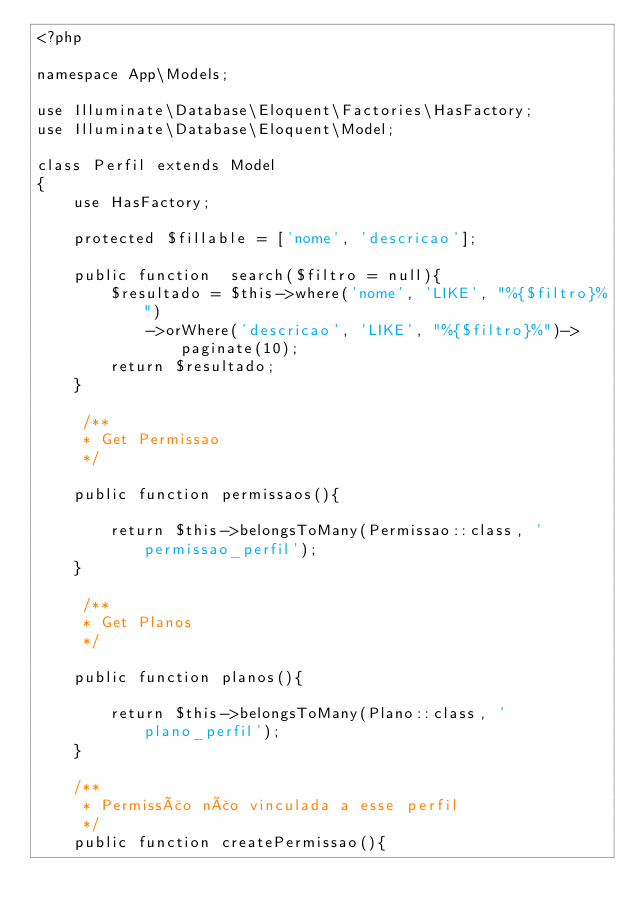Convert code to text. <code><loc_0><loc_0><loc_500><loc_500><_PHP_><?php

namespace App\Models;

use Illuminate\Database\Eloquent\Factories\HasFactory;
use Illuminate\Database\Eloquent\Model;

class Perfil extends Model
{
    use HasFactory;
    
    protected $fillable = ['nome', 'descricao'];

    public function  search($filtro = null){
        $resultado = $this->where('nome', 'LIKE', "%{$filtro}%")
            ->orWhere('descricao', 'LIKE', "%{$filtro}%")->paginate(10);
        return $resultado;
    }

     /**
     * Get Permissao
     */

    public function permissaos(){

        return $this->belongsToMany(Permissao::class, 'permissao_perfil');
    }

     /**
     * Get Planos
     */

    public function planos(){

        return $this->belongsToMany(Plano::class, 'plano_perfil');
    }

    /**
     * Permissão não vinculada a esse perfil
     */
    public function createPermissao(){
</code> 